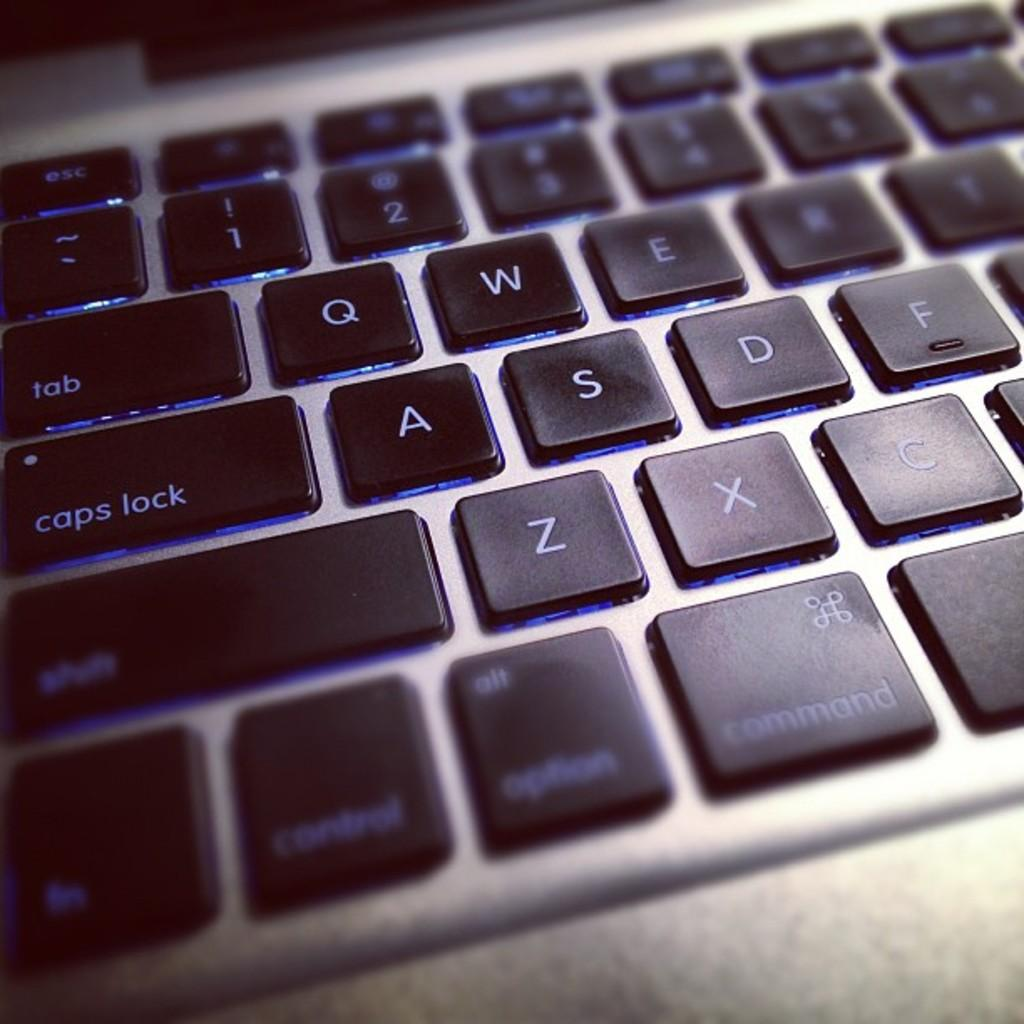<image>
Write a terse but informative summary of the picture. A close up of a keyboard with the caps lock button visible. 